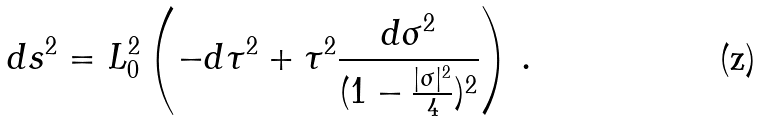Convert formula to latex. <formula><loc_0><loc_0><loc_500><loc_500>d s ^ { 2 } = L _ { 0 } ^ { 2 } \left ( - d \tau ^ { 2 } + \tau ^ { 2 } \frac { d \sigma ^ { 2 } } { ( 1 - \frac { | \sigma | ^ { 2 } } { 4 } ) ^ { 2 } } \right ) \, .</formula> 